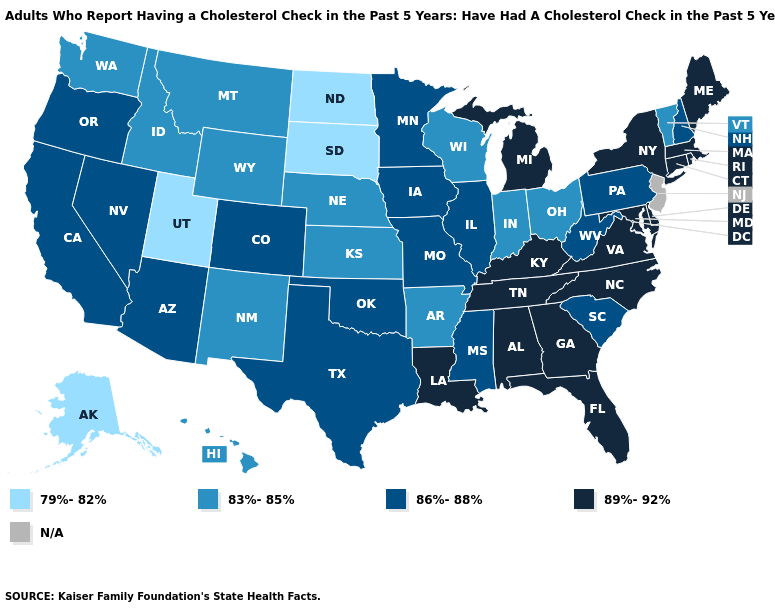What is the value of Oregon?
Answer briefly. 86%-88%. What is the highest value in the USA?
Short answer required. 89%-92%. Which states have the lowest value in the South?
Answer briefly. Arkansas. What is the lowest value in the Northeast?
Write a very short answer. 83%-85%. Among the states that border Indiana , does Kentucky have the highest value?
Answer briefly. Yes. Is the legend a continuous bar?
Be succinct. No. Is the legend a continuous bar?
Short answer required. No. What is the value of Tennessee?
Give a very brief answer. 89%-92%. Does Texas have the highest value in the South?
Answer briefly. No. What is the value of Georgia?
Concise answer only. 89%-92%. Name the states that have a value in the range 79%-82%?
Concise answer only. Alaska, North Dakota, South Dakota, Utah. What is the lowest value in states that border Massachusetts?
Short answer required. 83%-85%. What is the value of Nebraska?
Concise answer only. 83%-85%. Name the states that have a value in the range 86%-88%?
Concise answer only. Arizona, California, Colorado, Illinois, Iowa, Minnesota, Mississippi, Missouri, Nevada, New Hampshire, Oklahoma, Oregon, Pennsylvania, South Carolina, Texas, West Virginia. Does the first symbol in the legend represent the smallest category?
Answer briefly. Yes. 